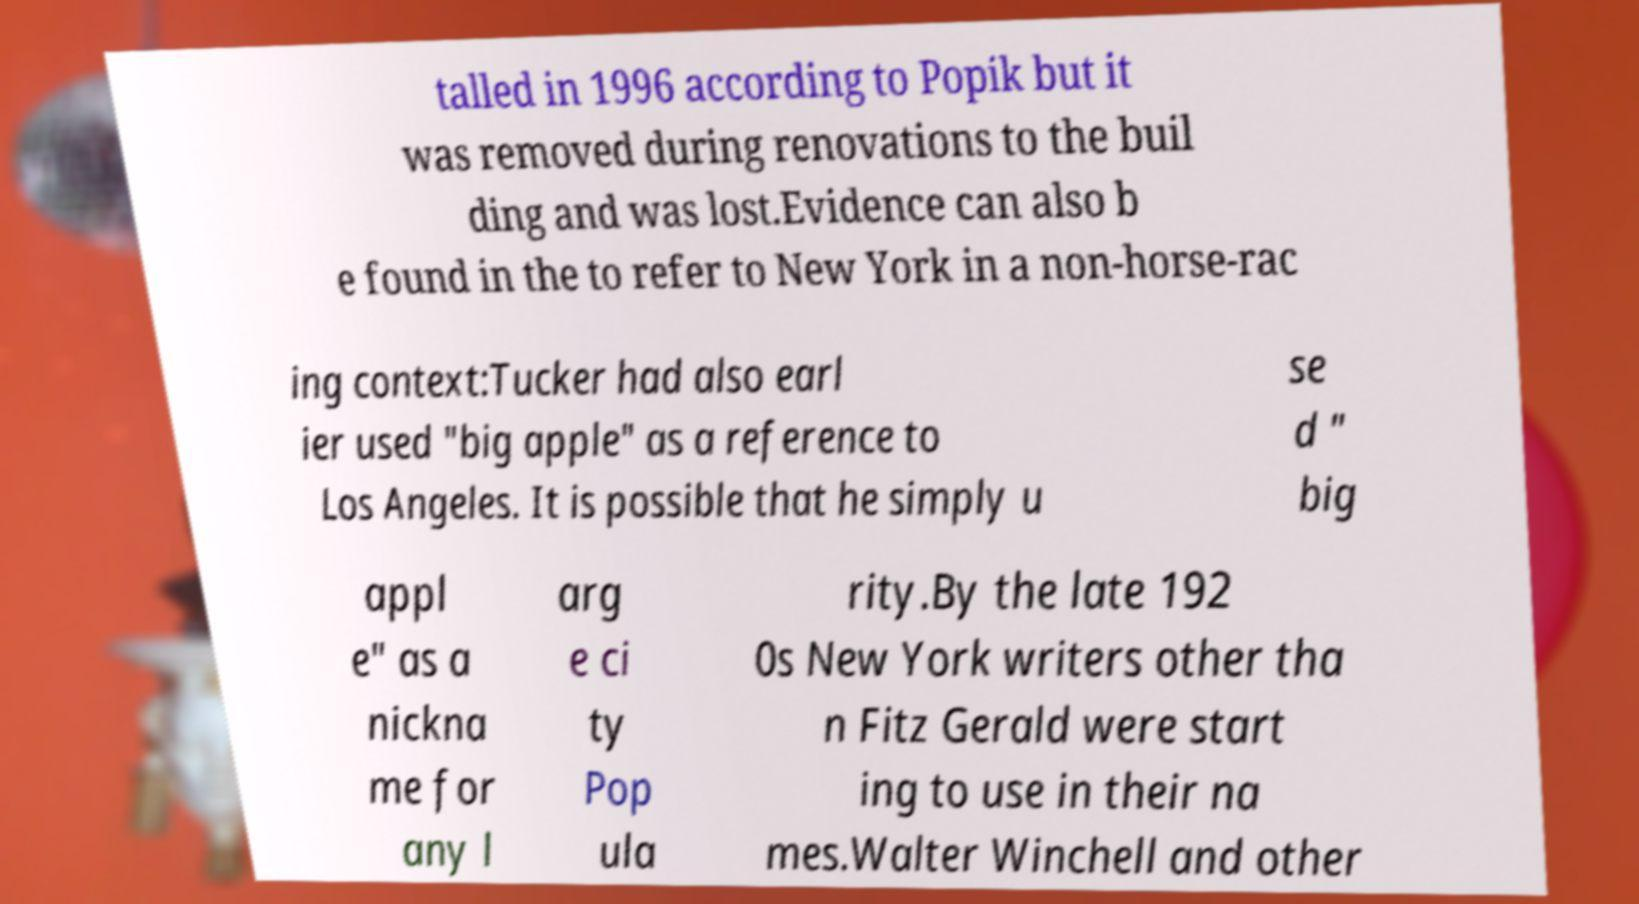Can you read and provide the text displayed in the image?This photo seems to have some interesting text. Can you extract and type it out for me? talled in 1996 according to Popik but it was removed during renovations to the buil ding and was lost.Evidence can also b e found in the to refer to New York in a non-horse-rac ing context:Tucker had also earl ier used "big apple" as a reference to Los Angeles. It is possible that he simply u se d " big appl e" as a nickna me for any l arg e ci ty Pop ula rity.By the late 192 0s New York writers other tha n Fitz Gerald were start ing to use in their na mes.Walter Winchell and other 